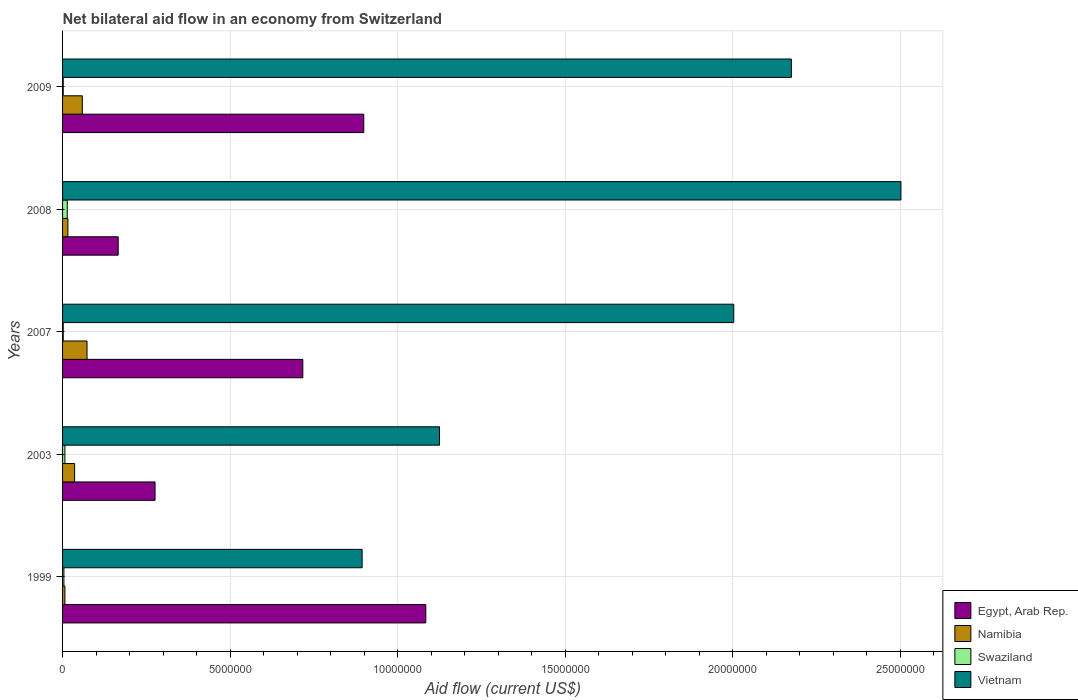Are the number of bars per tick equal to the number of legend labels?
Your answer should be compact. Yes. How many bars are there on the 4th tick from the top?
Make the answer very short. 4. How many bars are there on the 3rd tick from the bottom?
Keep it short and to the point. 4. What is the net bilateral aid flow in Namibia in 2007?
Offer a very short reply. 7.30e+05. Across all years, what is the maximum net bilateral aid flow in Swaziland?
Offer a very short reply. 1.40e+05. In which year was the net bilateral aid flow in Vietnam minimum?
Your answer should be compact. 1999. What is the difference between the net bilateral aid flow in Egypt, Arab Rep. in 2009 and the net bilateral aid flow in Vietnam in 2008?
Offer a terse response. -1.60e+07. What is the average net bilateral aid flow in Swaziland per year?
Give a very brief answer. 5.80e+04. In the year 2003, what is the difference between the net bilateral aid flow in Swaziland and net bilateral aid flow in Vietnam?
Ensure brevity in your answer.  -1.12e+07. What is the ratio of the net bilateral aid flow in Namibia in 2003 to that in 2008?
Offer a terse response. 2.25. Is the net bilateral aid flow in Vietnam in 2008 less than that in 2009?
Make the answer very short. No. What is the difference between the highest and the second highest net bilateral aid flow in Vietnam?
Keep it short and to the point. 3.27e+06. What is the difference between the highest and the lowest net bilateral aid flow in Vietnam?
Make the answer very short. 1.61e+07. In how many years, is the net bilateral aid flow in Vietnam greater than the average net bilateral aid flow in Vietnam taken over all years?
Provide a short and direct response. 3. What does the 3rd bar from the top in 2007 represents?
Keep it short and to the point. Namibia. What does the 1st bar from the bottom in 2008 represents?
Make the answer very short. Egypt, Arab Rep. What is the difference between two consecutive major ticks on the X-axis?
Provide a succinct answer. 5.00e+06. Are the values on the major ticks of X-axis written in scientific E-notation?
Your answer should be compact. No. Does the graph contain any zero values?
Ensure brevity in your answer.  No. Where does the legend appear in the graph?
Your answer should be very brief. Bottom right. How many legend labels are there?
Your response must be concise. 4. How are the legend labels stacked?
Make the answer very short. Vertical. What is the title of the graph?
Your response must be concise. Net bilateral aid flow in an economy from Switzerland. What is the label or title of the X-axis?
Keep it short and to the point. Aid flow (current US$). What is the label or title of the Y-axis?
Offer a terse response. Years. What is the Aid flow (current US$) of Egypt, Arab Rep. in 1999?
Your answer should be very brief. 1.08e+07. What is the Aid flow (current US$) in Namibia in 1999?
Ensure brevity in your answer.  7.00e+04. What is the Aid flow (current US$) in Swaziland in 1999?
Offer a terse response. 4.00e+04. What is the Aid flow (current US$) of Vietnam in 1999?
Your answer should be compact. 8.94e+06. What is the Aid flow (current US$) in Egypt, Arab Rep. in 2003?
Provide a short and direct response. 2.76e+06. What is the Aid flow (current US$) in Namibia in 2003?
Offer a very short reply. 3.60e+05. What is the Aid flow (current US$) in Vietnam in 2003?
Give a very brief answer. 1.12e+07. What is the Aid flow (current US$) in Egypt, Arab Rep. in 2007?
Your answer should be very brief. 7.17e+06. What is the Aid flow (current US$) in Namibia in 2007?
Offer a terse response. 7.30e+05. What is the Aid flow (current US$) in Swaziland in 2007?
Offer a terse response. 2.00e+04. What is the Aid flow (current US$) of Vietnam in 2007?
Give a very brief answer. 2.00e+07. What is the Aid flow (current US$) in Egypt, Arab Rep. in 2008?
Offer a terse response. 1.66e+06. What is the Aid flow (current US$) in Vietnam in 2008?
Offer a terse response. 2.50e+07. What is the Aid flow (current US$) in Egypt, Arab Rep. in 2009?
Offer a very short reply. 8.99e+06. What is the Aid flow (current US$) of Namibia in 2009?
Ensure brevity in your answer.  5.90e+05. What is the Aid flow (current US$) of Vietnam in 2009?
Offer a very short reply. 2.18e+07. Across all years, what is the maximum Aid flow (current US$) of Egypt, Arab Rep.?
Provide a short and direct response. 1.08e+07. Across all years, what is the maximum Aid flow (current US$) of Namibia?
Offer a terse response. 7.30e+05. Across all years, what is the maximum Aid flow (current US$) in Vietnam?
Your response must be concise. 2.50e+07. Across all years, what is the minimum Aid flow (current US$) of Egypt, Arab Rep.?
Your response must be concise. 1.66e+06. Across all years, what is the minimum Aid flow (current US$) in Namibia?
Provide a short and direct response. 7.00e+04. Across all years, what is the minimum Aid flow (current US$) of Swaziland?
Your answer should be compact. 2.00e+04. Across all years, what is the minimum Aid flow (current US$) in Vietnam?
Provide a succinct answer. 8.94e+06. What is the total Aid flow (current US$) in Egypt, Arab Rep. in the graph?
Offer a very short reply. 3.14e+07. What is the total Aid flow (current US$) in Namibia in the graph?
Offer a very short reply. 1.91e+06. What is the total Aid flow (current US$) in Vietnam in the graph?
Provide a short and direct response. 8.70e+07. What is the difference between the Aid flow (current US$) of Egypt, Arab Rep. in 1999 and that in 2003?
Offer a terse response. 8.08e+06. What is the difference between the Aid flow (current US$) in Namibia in 1999 and that in 2003?
Make the answer very short. -2.90e+05. What is the difference between the Aid flow (current US$) in Swaziland in 1999 and that in 2003?
Give a very brief answer. -3.00e+04. What is the difference between the Aid flow (current US$) in Vietnam in 1999 and that in 2003?
Ensure brevity in your answer.  -2.31e+06. What is the difference between the Aid flow (current US$) in Egypt, Arab Rep. in 1999 and that in 2007?
Your answer should be very brief. 3.67e+06. What is the difference between the Aid flow (current US$) of Namibia in 1999 and that in 2007?
Provide a short and direct response. -6.60e+05. What is the difference between the Aid flow (current US$) in Swaziland in 1999 and that in 2007?
Your answer should be compact. 2.00e+04. What is the difference between the Aid flow (current US$) in Vietnam in 1999 and that in 2007?
Make the answer very short. -1.11e+07. What is the difference between the Aid flow (current US$) of Egypt, Arab Rep. in 1999 and that in 2008?
Offer a very short reply. 9.18e+06. What is the difference between the Aid flow (current US$) of Vietnam in 1999 and that in 2008?
Your answer should be very brief. -1.61e+07. What is the difference between the Aid flow (current US$) of Egypt, Arab Rep. in 1999 and that in 2009?
Make the answer very short. 1.85e+06. What is the difference between the Aid flow (current US$) in Namibia in 1999 and that in 2009?
Offer a very short reply. -5.20e+05. What is the difference between the Aid flow (current US$) of Vietnam in 1999 and that in 2009?
Offer a very short reply. -1.28e+07. What is the difference between the Aid flow (current US$) in Egypt, Arab Rep. in 2003 and that in 2007?
Offer a very short reply. -4.41e+06. What is the difference between the Aid flow (current US$) of Namibia in 2003 and that in 2007?
Provide a succinct answer. -3.70e+05. What is the difference between the Aid flow (current US$) in Swaziland in 2003 and that in 2007?
Provide a succinct answer. 5.00e+04. What is the difference between the Aid flow (current US$) in Vietnam in 2003 and that in 2007?
Offer a terse response. -8.78e+06. What is the difference between the Aid flow (current US$) of Egypt, Arab Rep. in 2003 and that in 2008?
Your answer should be very brief. 1.10e+06. What is the difference between the Aid flow (current US$) in Vietnam in 2003 and that in 2008?
Your answer should be very brief. -1.38e+07. What is the difference between the Aid flow (current US$) of Egypt, Arab Rep. in 2003 and that in 2009?
Ensure brevity in your answer.  -6.23e+06. What is the difference between the Aid flow (current US$) in Vietnam in 2003 and that in 2009?
Your response must be concise. -1.05e+07. What is the difference between the Aid flow (current US$) in Egypt, Arab Rep. in 2007 and that in 2008?
Your answer should be compact. 5.51e+06. What is the difference between the Aid flow (current US$) in Namibia in 2007 and that in 2008?
Keep it short and to the point. 5.70e+05. What is the difference between the Aid flow (current US$) of Vietnam in 2007 and that in 2008?
Your answer should be very brief. -4.99e+06. What is the difference between the Aid flow (current US$) of Egypt, Arab Rep. in 2007 and that in 2009?
Ensure brevity in your answer.  -1.82e+06. What is the difference between the Aid flow (current US$) in Namibia in 2007 and that in 2009?
Your answer should be compact. 1.40e+05. What is the difference between the Aid flow (current US$) of Vietnam in 2007 and that in 2009?
Provide a succinct answer. -1.72e+06. What is the difference between the Aid flow (current US$) in Egypt, Arab Rep. in 2008 and that in 2009?
Ensure brevity in your answer.  -7.33e+06. What is the difference between the Aid flow (current US$) of Namibia in 2008 and that in 2009?
Provide a succinct answer. -4.30e+05. What is the difference between the Aid flow (current US$) in Vietnam in 2008 and that in 2009?
Ensure brevity in your answer.  3.27e+06. What is the difference between the Aid flow (current US$) in Egypt, Arab Rep. in 1999 and the Aid flow (current US$) in Namibia in 2003?
Your answer should be compact. 1.05e+07. What is the difference between the Aid flow (current US$) of Egypt, Arab Rep. in 1999 and the Aid flow (current US$) of Swaziland in 2003?
Give a very brief answer. 1.08e+07. What is the difference between the Aid flow (current US$) in Egypt, Arab Rep. in 1999 and the Aid flow (current US$) in Vietnam in 2003?
Your answer should be compact. -4.10e+05. What is the difference between the Aid flow (current US$) of Namibia in 1999 and the Aid flow (current US$) of Vietnam in 2003?
Offer a terse response. -1.12e+07. What is the difference between the Aid flow (current US$) of Swaziland in 1999 and the Aid flow (current US$) of Vietnam in 2003?
Make the answer very short. -1.12e+07. What is the difference between the Aid flow (current US$) of Egypt, Arab Rep. in 1999 and the Aid flow (current US$) of Namibia in 2007?
Make the answer very short. 1.01e+07. What is the difference between the Aid flow (current US$) of Egypt, Arab Rep. in 1999 and the Aid flow (current US$) of Swaziland in 2007?
Make the answer very short. 1.08e+07. What is the difference between the Aid flow (current US$) in Egypt, Arab Rep. in 1999 and the Aid flow (current US$) in Vietnam in 2007?
Provide a succinct answer. -9.19e+06. What is the difference between the Aid flow (current US$) of Namibia in 1999 and the Aid flow (current US$) of Vietnam in 2007?
Your answer should be compact. -2.00e+07. What is the difference between the Aid flow (current US$) in Swaziland in 1999 and the Aid flow (current US$) in Vietnam in 2007?
Your answer should be very brief. -2.00e+07. What is the difference between the Aid flow (current US$) in Egypt, Arab Rep. in 1999 and the Aid flow (current US$) in Namibia in 2008?
Provide a short and direct response. 1.07e+07. What is the difference between the Aid flow (current US$) in Egypt, Arab Rep. in 1999 and the Aid flow (current US$) in Swaziland in 2008?
Give a very brief answer. 1.07e+07. What is the difference between the Aid flow (current US$) in Egypt, Arab Rep. in 1999 and the Aid flow (current US$) in Vietnam in 2008?
Offer a very short reply. -1.42e+07. What is the difference between the Aid flow (current US$) in Namibia in 1999 and the Aid flow (current US$) in Swaziland in 2008?
Offer a very short reply. -7.00e+04. What is the difference between the Aid flow (current US$) in Namibia in 1999 and the Aid flow (current US$) in Vietnam in 2008?
Offer a terse response. -2.50e+07. What is the difference between the Aid flow (current US$) of Swaziland in 1999 and the Aid flow (current US$) of Vietnam in 2008?
Make the answer very short. -2.50e+07. What is the difference between the Aid flow (current US$) of Egypt, Arab Rep. in 1999 and the Aid flow (current US$) of Namibia in 2009?
Provide a succinct answer. 1.02e+07. What is the difference between the Aid flow (current US$) of Egypt, Arab Rep. in 1999 and the Aid flow (current US$) of Swaziland in 2009?
Your answer should be compact. 1.08e+07. What is the difference between the Aid flow (current US$) of Egypt, Arab Rep. in 1999 and the Aid flow (current US$) of Vietnam in 2009?
Offer a very short reply. -1.09e+07. What is the difference between the Aid flow (current US$) of Namibia in 1999 and the Aid flow (current US$) of Vietnam in 2009?
Keep it short and to the point. -2.17e+07. What is the difference between the Aid flow (current US$) in Swaziland in 1999 and the Aid flow (current US$) in Vietnam in 2009?
Your answer should be very brief. -2.17e+07. What is the difference between the Aid flow (current US$) of Egypt, Arab Rep. in 2003 and the Aid flow (current US$) of Namibia in 2007?
Make the answer very short. 2.03e+06. What is the difference between the Aid flow (current US$) of Egypt, Arab Rep. in 2003 and the Aid flow (current US$) of Swaziland in 2007?
Provide a short and direct response. 2.74e+06. What is the difference between the Aid flow (current US$) in Egypt, Arab Rep. in 2003 and the Aid flow (current US$) in Vietnam in 2007?
Give a very brief answer. -1.73e+07. What is the difference between the Aid flow (current US$) of Namibia in 2003 and the Aid flow (current US$) of Swaziland in 2007?
Keep it short and to the point. 3.40e+05. What is the difference between the Aid flow (current US$) in Namibia in 2003 and the Aid flow (current US$) in Vietnam in 2007?
Offer a terse response. -1.97e+07. What is the difference between the Aid flow (current US$) in Swaziland in 2003 and the Aid flow (current US$) in Vietnam in 2007?
Your response must be concise. -2.00e+07. What is the difference between the Aid flow (current US$) of Egypt, Arab Rep. in 2003 and the Aid flow (current US$) of Namibia in 2008?
Your answer should be compact. 2.60e+06. What is the difference between the Aid flow (current US$) in Egypt, Arab Rep. in 2003 and the Aid flow (current US$) in Swaziland in 2008?
Your answer should be compact. 2.62e+06. What is the difference between the Aid flow (current US$) of Egypt, Arab Rep. in 2003 and the Aid flow (current US$) of Vietnam in 2008?
Offer a very short reply. -2.23e+07. What is the difference between the Aid flow (current US$) of Namibia in 2003 and the Aid flow (current US$) of Vietnam in 2008?
Your answer should be compact. -2.47e+07. What is the difference between the Aid flow (current US$) of Swaziland in 2003 and the Aid flow (current US$) of Vietnam in 2008?
Provide a succinct answer. -2.50e+07. What is the difference between the Aid flow (current US$) in Egypt, Arab Rep. in 2003 and the Aid flow (current US$) in Namibia in 2009?
Make the answer very short. 2.17e+06. What is the difference between the Aid flow (current US$) in Egypt, Arab Rep. in 2003 and the Aid flow (current US$) in Swaziland in 2009?
Ensure brevity in your answer.  2.74e+06. What is the difference between the Aid flow (current US$) in Egypt, Arab Rep. in 2003 and the Aid flow (current US$) in Vietnam in 2009?
Your response must be concise. -1.90e+07. What is the difference between the Aid flow (current US$) of Namibia in 2003 and the Aid flow (current US$) of Swaziland in 2009?
Offer a very short reply. 3.40e+05. What is the difference between the Aid flow (current US$) of Namibia in 2003 and the Aid flow (current US$) of Vietnam in 2009?
Provide a short and direct response. -2.14e+07. What is the difference between the Aid flow (current US$) in Swaziland in 2003 and the Aid flow (current US$) in Vietnam in 2009?
Offer a very short reply. -2.17e+07. What is the difference between the Aid flow (current US$) of Egypt, Arab Rep. in 2007 and the Aid flow (current US$) of Namibia in 2008?
Provide a short and direct response. 7.01e+06. What is the difference between the Aid flow (current US$) in Egypt, Arab Rep. in 2007 and the Aid flow (current US$) in Swaziland in 2008?
Offer a terse response. 7.03e+06. What is the difference between the Aid flow (current US$) in Egypt, Arab Rep. in 2007 and the Aid flow (current US$) in Vietnam in 2008?
Give a very brief answer. -1.78e+07. What is the difference between the Aid flow (current US$) of Namibia in 2007 and the Aid flow (current US$) of Swaziland in 2008?
Ensure brevity in your answer.  5.90e+05. What is the difference between the Aid flow (current US$) in Namibia in 2007 and the Aid flow (current US$) in Vietnam in 2008?
Keep it short and to the point. -2.43e+07. What is the difference between the Aid flow (current US$) of Swaziland in 2007 and the Aid flow (current US$) of Vietnam in 2008?
Keep it short and to the point. -2.50e+07. What is the difference between the Aid flow (current US$) of Egypt, Arab Rep. in 2007 and the Aid flow (current US$) of Namibia in 2009?
Provide a succinct answer. 6.58e+06. What is the difference between the Aid flow (current US$) in Egypt, Arab Rep. in 2007 and the Aid flow (current US$) in Swaziland in 2009?
Keep it short and to the point. 7.15e+06. What is the difference between the Aid flow (current US$) of Egypt, Arab Rep. in 2007 and the Aid flow (current US$) of Vietnam in 2009?
Your answer should be compact. -1.46e+07. What is the difference between the Aid flow (current US$) in Namibia in 2007 and the Aid flow (current US$) in Swaziland in 2009?
Make the answer very short. 7.10e+05. What is the difference between the Aid flow (current US$) of Namibia in 2007 and the Aid flow (current US$) of Vietnam in 2009?
Make the answer very short. -2.10e+07. What is the difference between the Aid flow (current US$) in Swaziland in 2007 and the Aid flow (current US$) in Vietnam in 2009?
Your answer should be compact. -2.17e+07. What is the difference between the Aid flow (current US$) in Egypt, Arab Rep. in 2008 and the Aid flow (current US$) in Namibia in 2009?
Ensure brevity in your answer.  1.07e+06. What is the difference between the Aid flow (current US$) of Egypt, Arab Rep. in 2008 and the Aid flow (current US$) of Swaziland in 2009?
Your answer should be very brief. 1.64e+06. What is the difference between the Aid flow (current US$) in Egypt, Arab Rep. in 2008 and the Aid flow (current US$) in Vietnam in 2009?
Make the answer very short. -2.01e+07. What is the difference between the Aid flow (current US$) in Namibia in 2008 and the Aid flow (current US$) in Vietnam in 2009?
Your answer should be compact. -2.16e+07. What is the difference between the Aid flow (current US$) of Swaziland in 2008 and the Aid flow (current US$) of Vietnam in 2009?
Give a very brief answer. -2.16e+07. What is the average Aid flow (current US$) of Egypt, Arab Rep. per year?
Make the answer very short. 6.28e+06. What is the average Aid flow (current US$) of Namibia per year?
Offer a very short reply. 3.82e+05. What is the average Aid flow (current US$) of Swaziland per year?
Offer a very short reply. 5.80e+04. What is the average Aid flow (current US$) in Vietnam per year?
Offer a terse response. 1.74e+07. In the year 1999, what is the difference between the Aid flow (current US$) in Egypt, Arab Rep. and Aid flow (current US$) in Namibia?
Give a very brief answer. 1.08e+07. In the year 1999, what is the difference between the Aid flow (current US$) in Egypt, Arab Rep. and Aid flow (current US$) in Swaziland?
Offer a terse response. 1.08e+07. In the year 1999, what is the difference between the Aid flow (current US$) in Egypt, Arab Rep. and Aid flow (current US$) in Vietnam?
Ensure brevity in your answer.  1.90e+06. In the year 1999, what is the difference between the Aid flow (current US$) in Namibia and Aid flow (current US$) in Swaziland?
Provide a succinct answer. 3.00e+04. In the year 1999, what is the difference between the Aid flow (current US$) of Namibia and Aid flow (current US$) of Vietnam?
Provide a succinct answer. -8.87e+06. In the year 1999, what is the difference between the Aid flow (current US$) in Swaziland and Aid flow (current US$) in Vietnam?
Make the answer very short. -8.90e+06. In the year 2003, what is the difference between the Aid flow (current US$) in Egypt, Arab Rep. and Aid flow (current US$) in Namibia?
Your answer should be very brief. 2.40e+06. In the year 2003, what is the difference between the Aid flow (current US$) of Egypt, Arab Rep. and Aid flow (current US$) of Swaziland?
Keep it short and to the point. 2.69e+06. In the year 2003, what is the difference between the Aid flow (current US$) of Egypt, Arab Rep. and Aid flow (current US$) of Vietnam?
Give a very brief answer. -8.49e+06. In the year 2003, what is the difference between the Aid flow (current US$) in Namibia and Aid flow (current US$) in Swaziland?
Make the answer very short. 2.90e+05. In the year 2003, what is the difference between the Aid flow (current US$) in Namibia and Aid flow (current US$) in Vietnam?
Your response must be concise. -1.09e+07. In the year 2003, what is the difference between the Aid flow (current US$) in Swaziland and Aid flow (current US$) in Vietnam?
Give a very brief answer. -1.12e+07. In the year 2007, what is the difference between the Aid flow (current US$) of Egypt, Arab Rep. and Aid flow (current US$) of Namibia?
Make the answer very short. 6.44e+06. In the year 2007, what is the difference between the Aid flow (current US$) in Egypt, Arab Rep. and Aid flow (current US$) in Swaziland?
Your response must be concise. 7.15e+06. In the year 2007, what is the difference between the Aid flow (current US$) of Egypt, Arab Rep. and Aid flow (current US$) of Vietnam?
Keep it short and to the point. -1.29e+07. In the year 2007, what is the difference between the Aid flow (current US$) in Namibia and Aid flow (current US$) in Swaziland?
Provide a succinct answer. 7.10e+05. In the year 2007, what is the difference between the Aid flow (current US$) of Namibia and Aid flow (current US$) of Vietnam?
Keep it short and to the point. -1.93e+07. In the year 2007, what is the difference between the Aid flow (current US$) in Swaziland and Aid flow (current US$) in Vietnam?
Give a very brief answer. -2.00e+07. In the year 2008, what is the difference between the Aid flow (current US$) in Egypt, Arab Rep. and Aid flow (current US$) in Namibia?
Provide a short and direct response. 1.50e+06. In the year 2008, what is the difference between the Aid flow (current US$) of Egypt, Arab Rep. and Aid flow (current US$) of Swaziland?
Provide a short and direct response. 1.52e+06. In the year 2008, what is the difference between the Aid flow (current US$) in Egypt, Arab Rep. and Aid flow (current US$) in Vietnam?
Offer a very short reply. -2.34e+07. In the year 2008, what is the difference between the Aid flow (current US$) of Namibia and Aid flow (current US$) of Swaziland?
Provide a short and direct response. 2.00e+04. In the year 2008, what is the difference between the Aid flow (current US$) in Namibia and Aid flow (current US$) in Vietnam?
Offer a very short reply. -2.49e+07. In the year 2008, what is the difference between the Aid flow (current US$) in Swaziland and Aid flow (current US$) in Vietnam?
Offer a terse response. -2.49e+07. In the year 2009, what is the difference between the Aid flow (current US$) of Egypt, Arab Rep. and Aid flow (current US$) of Namibia?
Offer a very short reply. 8.40e+06. In the year 2009, what is the difference between the Aid flow (current US$) in Egypt, Arab Rep. and Aid flow (current US$) in Swaziland?
Keep it short and to the point. 8.97e+06. In the year 2009, what is the difference between the Aid flow (current US$) in Egypt, Arab Rep. and Aid flow (current US$) in Vietnam?
Offer a very short reply. -1.28e+07. In the year 2009, what is the difference between the Aid flow (current US$) of Namibia and Aid flow (current US$) of Swaziland?
Your answer should be compact. 5.70e+05. In the year 2009, what is the difference between the Aid flow (current US$) of Namibia and Aid flow (current US$) of Vietnam?
Keep it short and to the point. -2.12e+07. In the year 2009, what is the difference between the Aid flow (current US$) of Swaziland and Aid flow (current US$) of Vietnam?
Your response must be concise. -2.17e+07. What is the ratio of the Aid flow (current US$) in Egypt, Arab Rep. in 1999 to that in 2003?
Provide a short and direct response. 3.93. What is the ratio of the Aid flow (current US$) of Namibia in 1999 to that in 2003?
Your response must be concise. 0.19. What is the ratio of the Aid flow (current US$) in Swaziland in 1999 to that in 2003?
Keep it short and to the point. 0.57. What is the ratio of the Aid flow (current US$) of Vietnam in 1999 to that in 2003?
Make the answer very short. 0.79. What is the ratio of the Aid flow (current US$) in Egypt, Arab Rep. in 1999 to that in 2007?
Your answer should be compact. 1.51. What is the ratio of the Aid flow (current US$) in Namibia in 1999 to that in 2007?
Ensure brevity in your answer.  0.1. What is the ratio of the Aid flow (current US$) of Vietnam in 1999 to that in 2007?
Ensure brevity in your answer.  0.45. What is the ratio of the Aid flow (current US$) of Egypt, Arab Rep. in 1999 to that in 2008?
Provide a succinct answer. 6.53. What is the ratio of the Aid flow (current US$) in Namibia in 1999 to that in 2008?
Your response must be concise. 0.44. What is the ratio of the Aid flow (current US$) of Swaziland in 1999 to that in 2008?
Make the answer very short. 0.29. What is the ratio of the Aid flow (current US$) in Vietnam in 1999 to that in 2008?
Your response must be concise. 0.36. What is the ratio of the Aid flow (current US$) of Egypt, Arab Rep. in 1999 to that in 2009?
Give a very brief answer. 1.21. What is the ratio of the Aid flow (current US$) in Namibia in 1999 to that in 2009?
Provide a succinct answer. 0.12. What is the ratio of the Aid flow (current US$) of Vietnam in 1999 to that in 2009?
Provide a short and direct response. 0.41. What is the ratio of the Aid flow (current US$) in Egypt, Arab Rep. in 2003 to that in 2007?
Provide a short and direct response. 0.38. What is the ratio of the Aid flow (current US$) of Namibia in 2003 to that in 2007?
Ensure brevity in your answer.  0.49. What is the ratio of the Aid flow (current US$) of Swaziland in 2003 to that in 2007?
Provide a short and direct response. 3.5. What is the ratio of the Aid flow (current US$) of Vietnam in 2003 to that in 2007?
Ensure brevity in your answer.  0.56. What is the ratio of the Aid flow (current US$) in Egypt, Arab Rep. in 2003 to that in 2008?
Make the answer very short. 1.66. What is the ratio of the Aid flow (current US$) in Namibia in 2003 to that in 2008?
Give a very brief answer. 2.25. What is the ratio of the Aid flow (current US$) in Vietnam in 2003 to that in 2008?
Make the answer very short. 0.45. What is the ratio of the Aid flow (current US$) in Egypt, Arab Rep. in 2003 to that in 2009?
Provide a short and direct response. 0.31. What is the ratio of the Aid flow (current US$) in Namibia in 2003 to that in 2009?
Provide a short and direct response. 0.61. What is the ratio of the Aid flow (current US$) of Vietnam in 2003 to that in 2009?
Give a very brief answer. 0.52. What is the ratio of the Aid flow (current US$) of Egypt, Arab Rep. in 2007 to that in 2008?
Provide a succinct answer. 4.32. What is the ratio of the Aid flow (current US$) of Namibia in 2007 to that in 2008?
Keep it short and to the point. 4.56. What is the ratio of the Aid flow (current US$) of Swaziland in 2007 to that in 2008?
Your answer should be very brief. 0.14. What is the ratio of the Aid flow (current US$) in Vietnam in 2007 to that in 2008?
Provide a short and direct response. 0.8. What is the ratio of the Aid flow (current US$) in Egypt, Arab Rep. in 2007 to that in 2009?
Your response must be concise. 0.8. What is the ratio of the Aid flow (current US$) in Namibia in 2007 to that in 2009?
Make the answer very short. 1.24. What is the ratio of the Aid flow (current US$) of Vietnam in 2007 to that in 2009?
Provide a succinct answer. 0.92. What is the ratio of the Aid flow (current US$) in Egypt, Arab Rep. in 2008 to that in 2009?
Offer a very short reply. 0.18. What is the ratio of the Aid flow (current US$) of Namibia in 2008 to that in 2009?
Your response must be concise. 0.27. What is the ratio of the Aid flow (current US$) in Swaziland in 2008 to that in 2009?
Your answer should be very brief. 7. What is the ratio of the Aid flow (current US$) of Vietnam in 2008 to that in 2009?
Your answer should be compact. 1.15. What is the difference between the highest and the second highest Aid flow (current US$) of Egypt, Arab Rep.?
Ensure brevity in your answer.  1.85e+06. What is the difference between the highest and the second highest Aid flow (current US$) of Namibia?
Ensure brevity in your answer.  1.40e+05. What is the difference between the highest and the second highest Aid flow (current US$) of Vietnam?
Your answer should be very brief. 3.27e+06. What is the difference between the highest and the lowest Aid flow (current US$) in Egypt, Arab Rep.?
Offer a very short reply. 9.18e+06. What is the difference between the highest and the lowest Aid flow (current US$) of Namibia?
Provide a short and direct response. 6.60e+05. What is the difference between the highest and the lowest Aid flow (current US$) in Swaziland?
Give a very brief answer. 1.20e+05. What is the difference between the highest and the lowest Aid flow (current US$) of Vietnam?
Provide a short and direct response. 1.61e+07. 